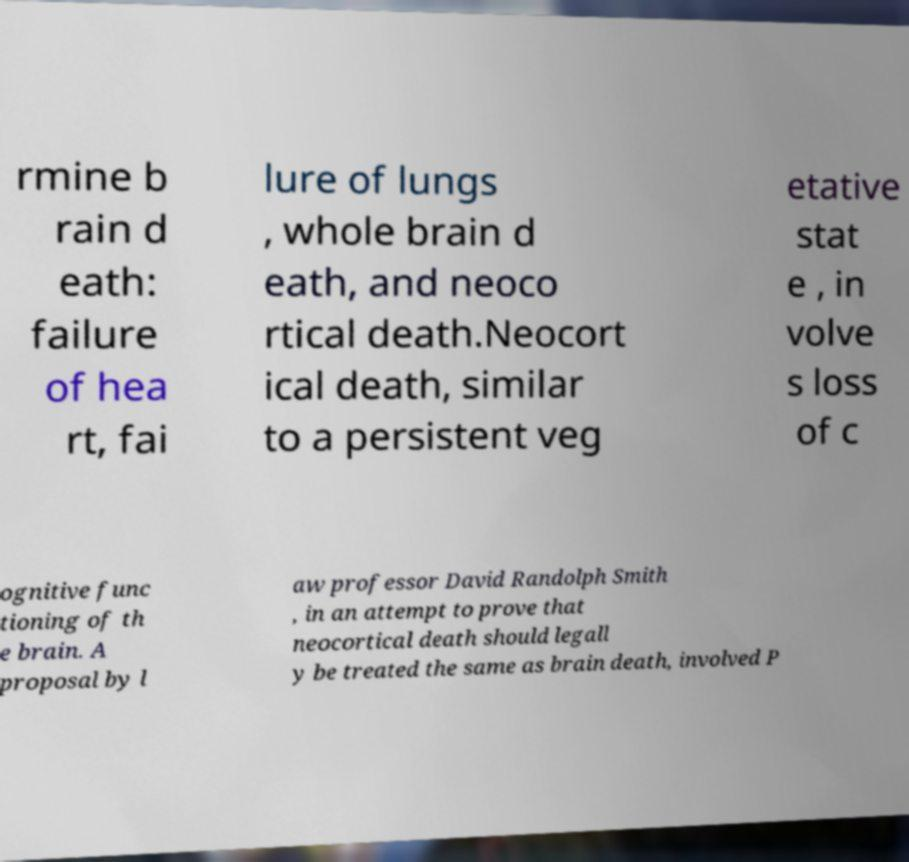I need the written content from this picture converted into text. Can you do that? rmine b rain d eath: failure of hea rt, fai lure of lungs , whole brain d eath, and neoco rtical death.Neocort ical death, similar to a persistent veg etative stat e , in volve s loss of c ognitive func tioning of th e brain. A proposal by l aw professor David Randolph Smith , in an attempt to prove that neocortical death should legall y be treated the same as brain death, involved P 